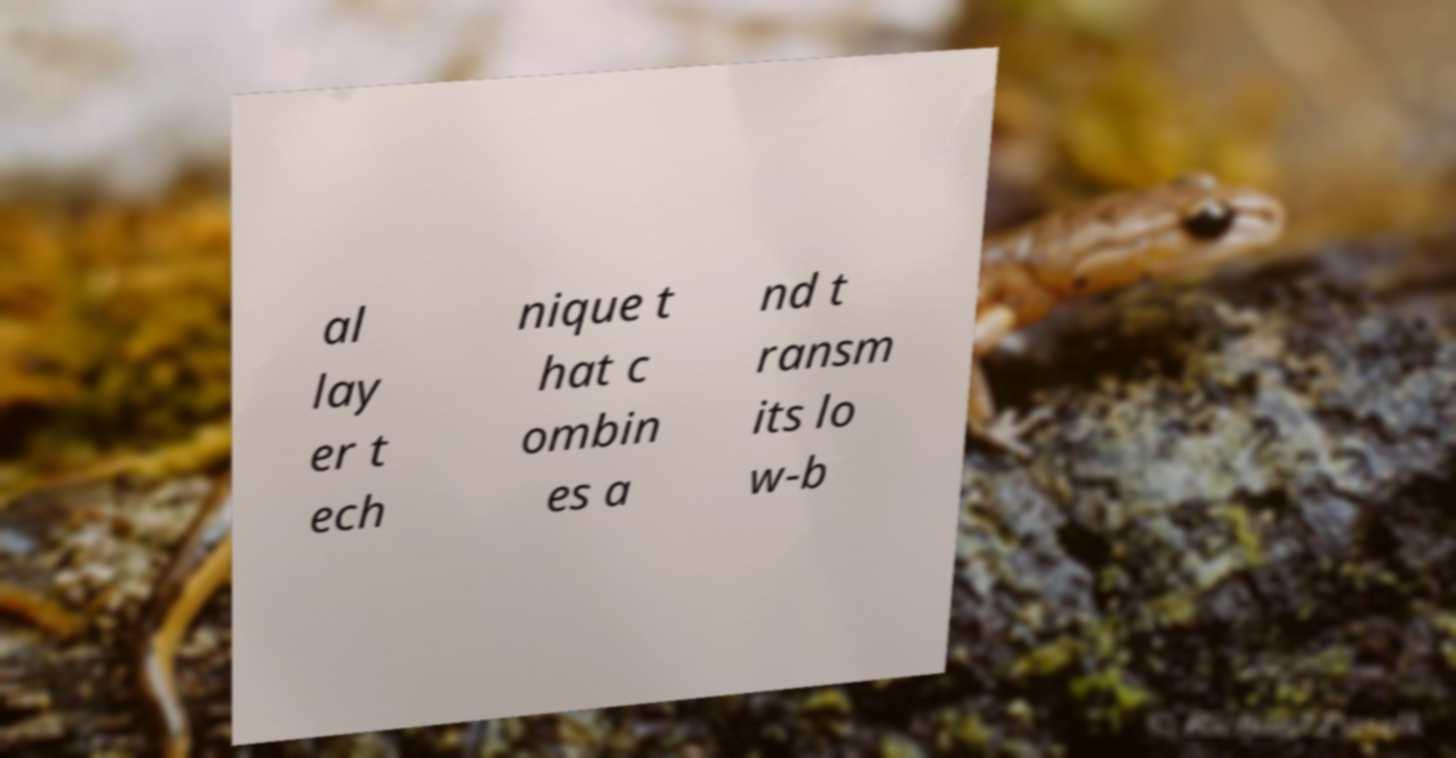Could you extract and type out the text from this image? al lay er t ech nique t hat c ombin es a nd t ransm its lo w-b 